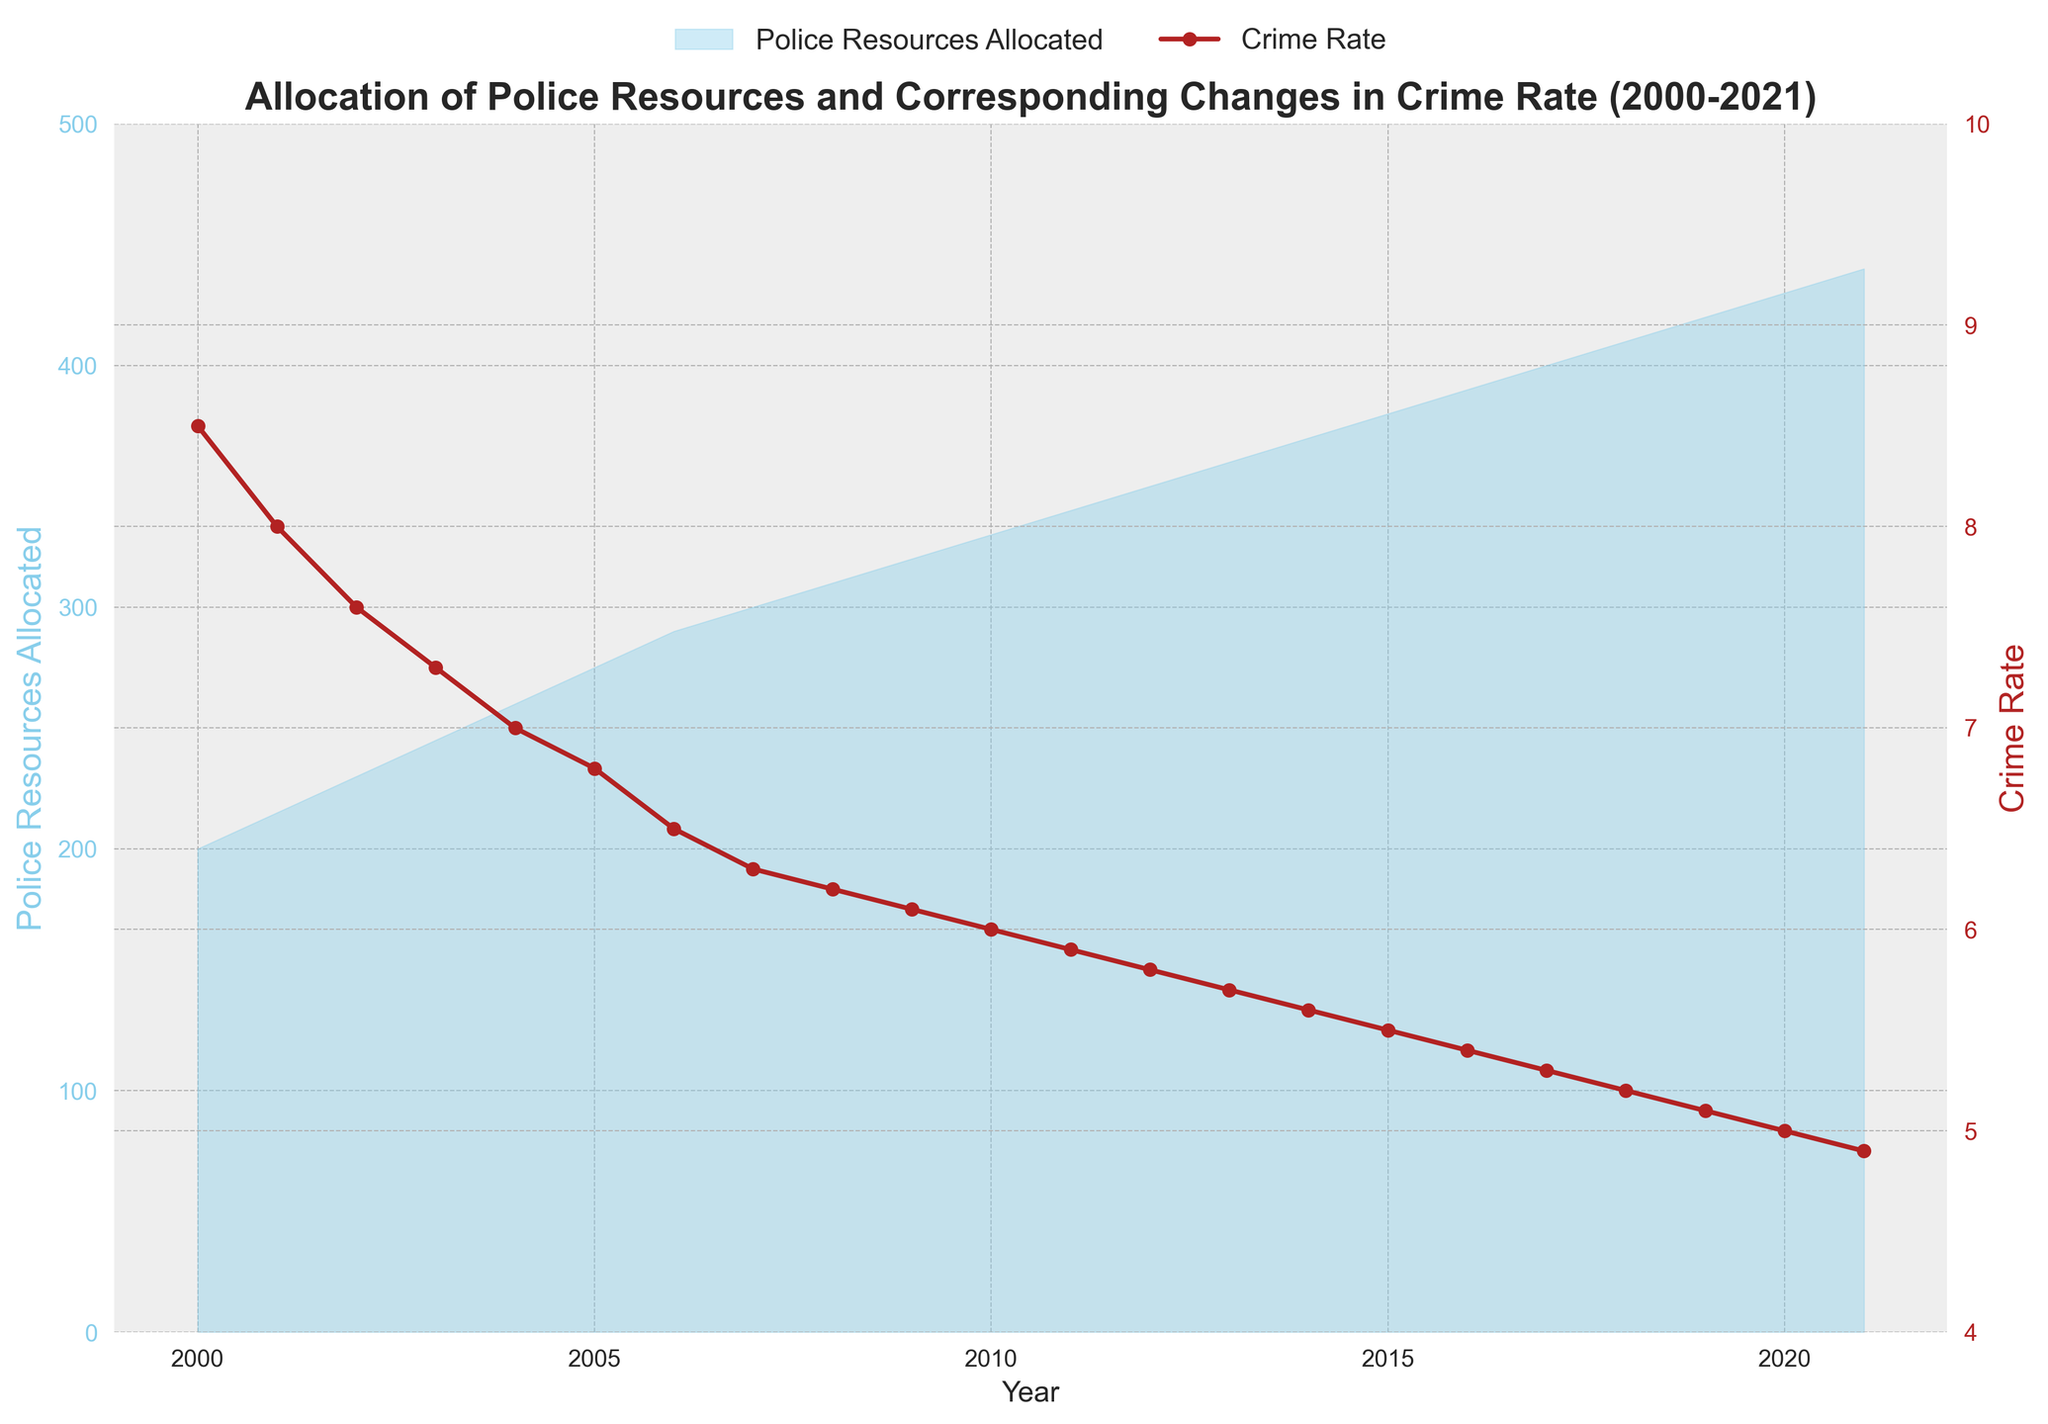what is the average police resources allocated between 2000 and 2010? Sum the police resources allocated from 2000 to 2010: 200 + 215 + 230 + 245 + 260 + 275 + 290 + 300 + 310 + 320 + 330 = 2975. There are 11 years in this period, so divide the sum by 11: 2975 / 11 = 270.5
Answer: 270.5 How did the crime rate change from 2005 to 2020? In 2005, the crime rate was 6.8. In 2020, the crime rate was 5.0. Subtract the crime rate in 2020 from the crime rate in 2005: 6.8 - 5.0 = 1.8. Thus, the crime rate decreased by 1.8 over this period.
Answer: Decreased by 1.8 Which year had the highest allocation of police resources? Look at the area chart of police resources allocated. The highest point is at the year 2021 with 440 units allocated.
Answer: 2021 What was the percentage decrease in the crime rate from 2000 to 2010? The crime rate in 2000 was 8.5 and in 2010 was 6.0. Subtract the 2010 rate from the 2000 rate: 8.5 - 6.0 = 2.5. Divide the decrease by the 2000 rate: 2.5 / 8.5 = 0.2941. Multiply by 100 to get the percentage: 0.2941 * 100 ≈ 29.41%.
Answer: 29.41% At which year did the crime rate fall below 6.0? The crime rate is shown with a red line and markers. In 2010, the crime rate is 6.0, and in 2011 the crime rate is 5.9. Therefore, it fell below 6.0 in 2011.
Answer: 2011 By how much did the police resources allocated increase from 2000 to 2021? The police resources allocated in 2000 were 200, and in 2021, they were 440. Subtract the resources in 2000 from those in 2021: 440 - 200 = 240.
Answer: 240 Which year had the most significant decrease in crime rate compared to the previous year? Examine the slope of the red line in the area-chart. The most significant drop is between 2020 and 2021, from 5.0 to 4.9, a decrease of 0.1.
Answer: 2021 What is the trend in police resources allocated and crime rate from 2000 to 2021? Observing the area-chart, the police resources allocated (sky blue area) consistently increase over the years. The crime rate (red line) consistently decreases over the same period.
Answer: Increasing resources, decreasing crime rate Compare the police resources allocated between 2010 and 2015. In 2010, the resources allocated were 330. In 2015, the resources were 380. The difference is 380 - 330 = 50 units.
Answer: Increased by 50 units In which years were the police resources allocated exactly 300 units or more? Markers at or above 300 units resources allocated are observed from 2007 onwards until 2021.
Answer: From 2007 to 2021 